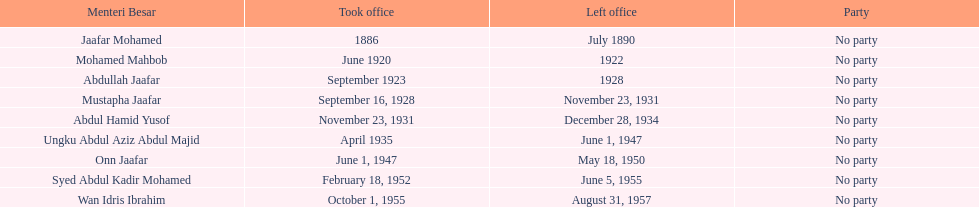Who took office after onn jaafar? Syed Abdul Kadir Mohamed. 